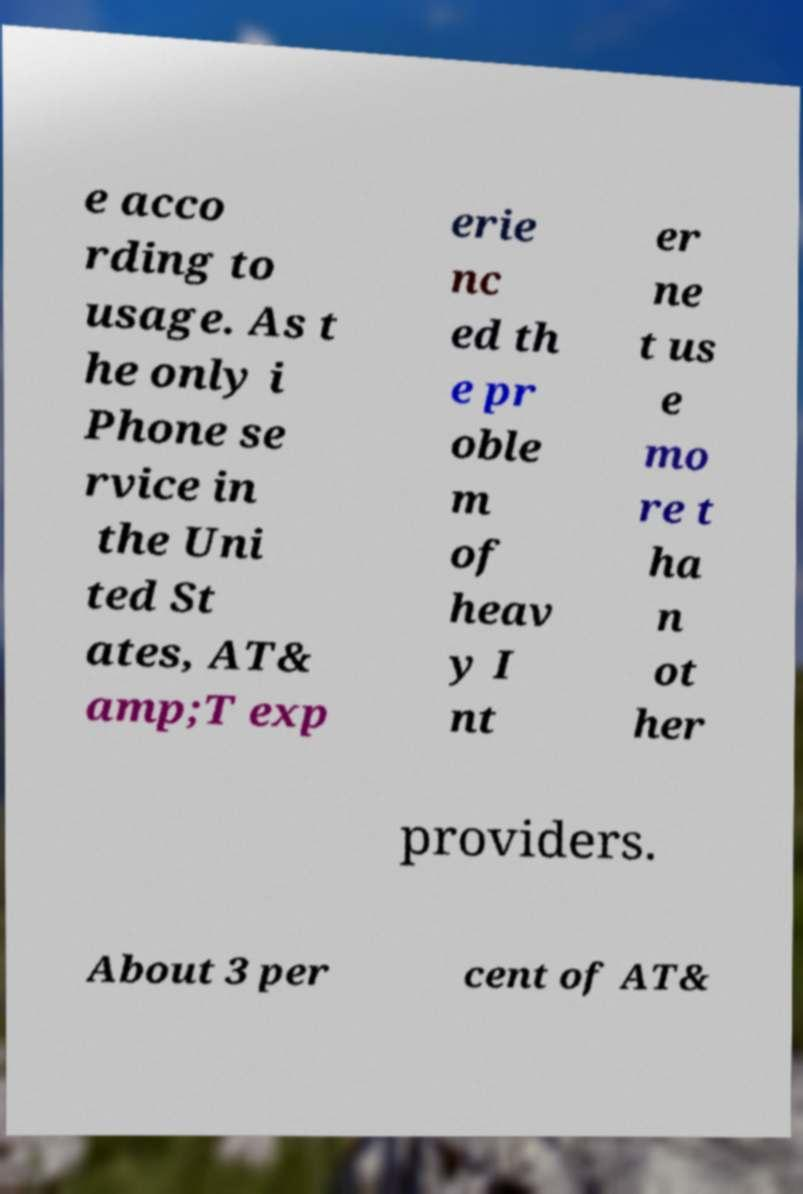Could you assist in decoding the text presented in this image and type it out clearly? e acco rding to usage. As t he only i Phone se rvice in the Uni ted St ates, AT& amp;T exp erie nc ed th e pr oble m of heav y I nt er ne t us e mo re t ha n ot her providers. About 3 per cent of AT& 